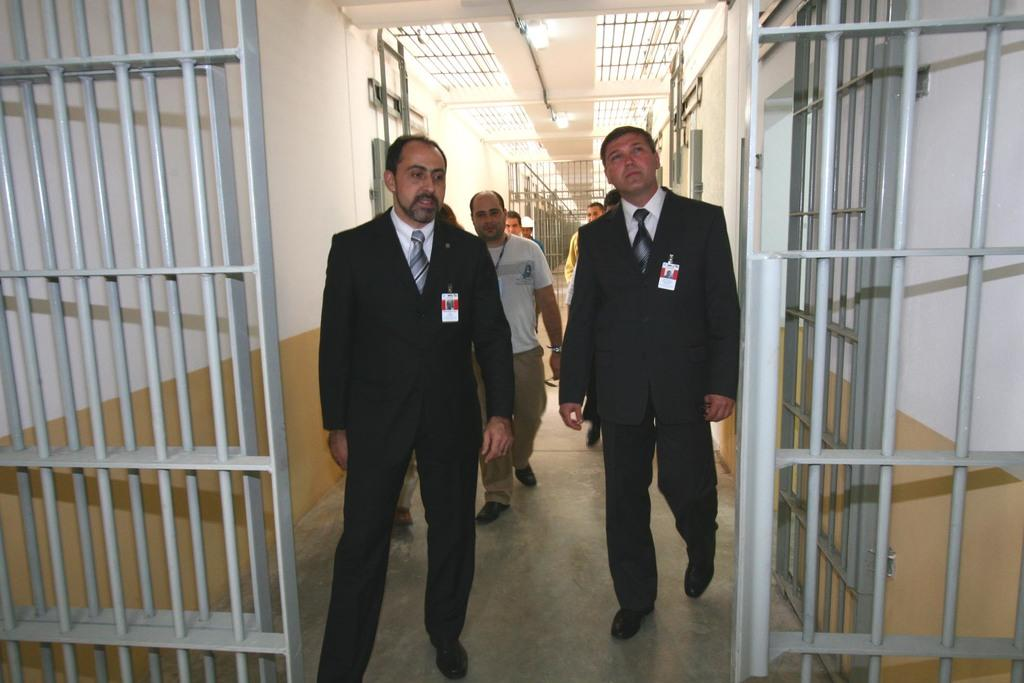What type of structure can be seen in the image? There are gates in the image. What are the people wearing in the image? People are wearing blazers and ties in the image. What can be used to identify individuals in the image? There are ID cards visible in the image. What is the setting of the image? There are walls and a floor in the image. What can be seen in the background of the image? There are rods, lights, and some objects visible in the background of the image. What are the people doing in the image? People are walking on the floor in the image. What type of vessel is being discovered in the image? There is no vessel being discovered in the image. Who needs to approve the actions of the people in the image? The image does not show any actions that require approval. 